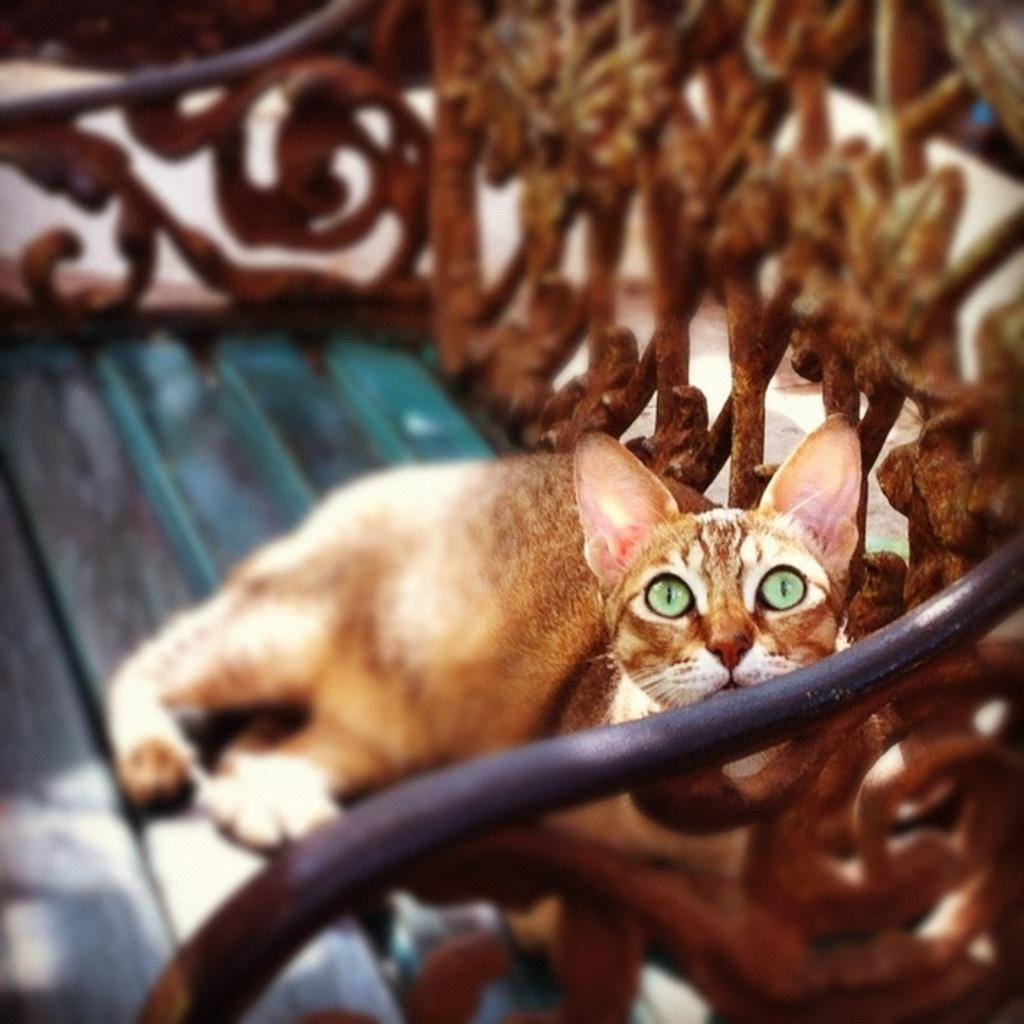What type of animal is in the image? There is a cat in the image. Where is the cat located? The cat is on a bench. What type of voice does the cat have in the image? The image is a still image, so it does not capture any sounds or voices. Therefore, we cannot determine the cat's voice from the image. 